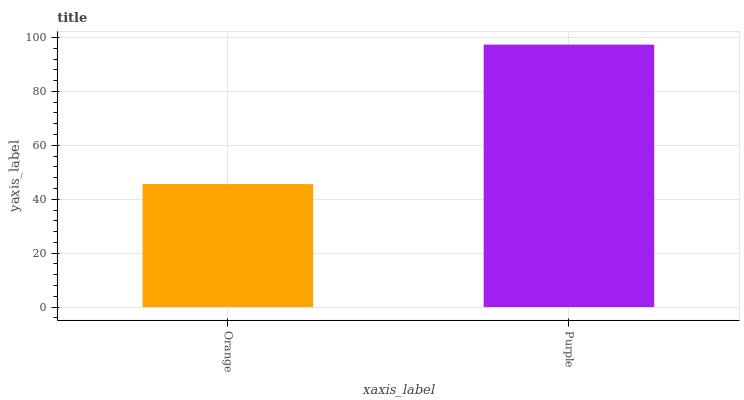Is Orange the minimum?
Answer yes or no. Yes. Is Purple the maximum?
Answer yes or no. Yes. Is Purple the minimum?
Answer yes or no. No. Is Purple greater than Orange?
Answer yes or no. Yes. Is Orange less than Purple?
Answer yes or no. Yes. Is Orange greater than Purple?
Answer yes or no. No. Is Purple less than Orange?
Answer yes or no. No. Is Purple the high median?
Answer yes or no. Yes. Is Orange the low median?
Answer yes or no. Yes. Is Orange the high median?
Answer yes or no. No. Is Purple the low median?
Answer yes or no. No. 